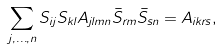Convert formula to latex. <formula><loc_0><loc_0><loc_500><loc_500>\sum _ { j , \dots , n } S _ { i j } S _ { k l } A _ { j l m n } \bar { S } _ { r m } \bar { S } _ { s n } = A _ { i k r s } ,</formula> 